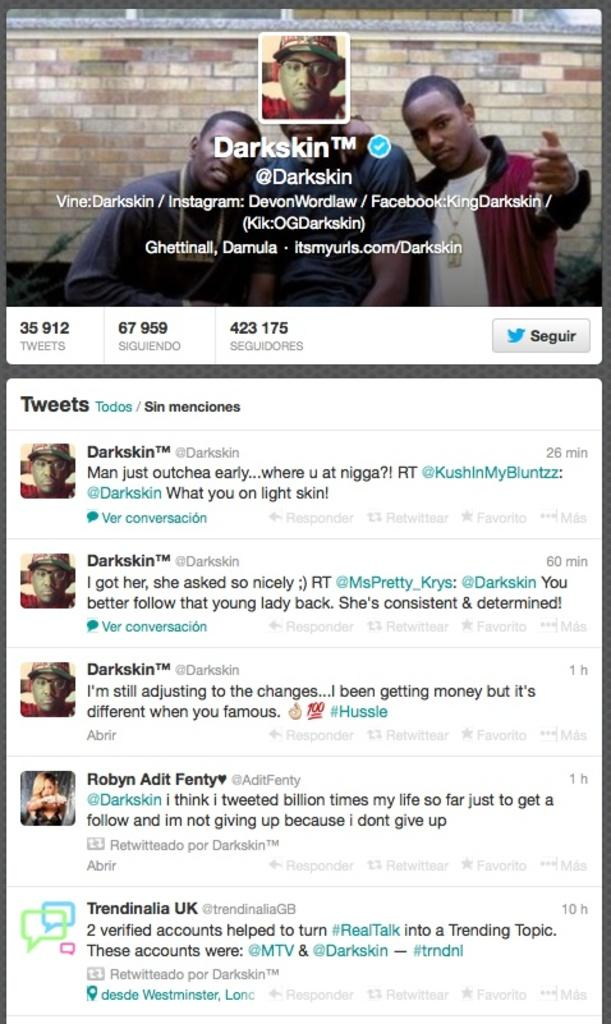What type of social media platform is represented in the image? The image is a page from a person's Twitter account. What can be seen in the profile photo on the page? The profile photo on the page is not visible in the image, but it is mentioned that there is a profile photo present. What is displayed as the cover photo on the page? There is a cover photo on the page, but its content is not specified in the provided facts. What type of content can be seen on the page? There are tweets visible on the page. What type of wool is used to make the pan in the image? There is no pan or wool mentioned in the image. 